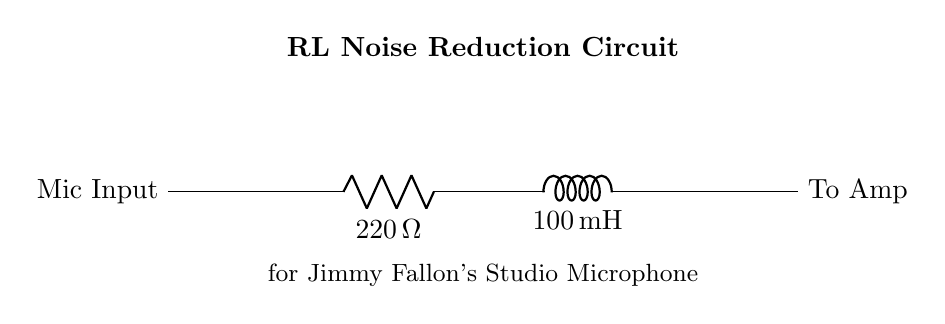What is the resistance value in this circuit? The circuit shows a resistor labeled "R" with the value stated explicitly as "220 Ω". Thus, the resistance value is directly given in the diagram.
Answer: 220 Ω What is the inductance value in this circuit? The circuit features an inductor labeled "L" with the value recorded as "100 mH". The inductance value is clearly stated in the diagram.
Answer: 100 mH What is the purpose of this RL circuit? The purpose is indicated in the circuit label, which states it is for "Noise Reduction" specifically for Jimmy Fallon's studio microphone. It suggests that the circuit is designed to reduce unwanted noise from the microphone input.
Answer: Noise Reduction Where does the microphone input connect in the circuit? The microphone input connects to the left side of the resistor "R", as seen in the diagram where there is a labeled input connection at that point.
Answer: To the left of the resistor How does the RL circuit help in noise reduction? An RL circuit helps in noise reduction by allowing low-frequency signals (like the voice) to pass through while attenuating higher-frequency noise due to the nature of inductors which resist changes in current. This behavior is typical of RL circuits.
Answer: By allowing low frequencies to pass What will happen if the value of the resistor is increased? Increasing the resistance would reduce the current flow in the circuit, potentially resulting in a lower output signal level to the amplifier, which could affect the overall gain and effectiveness in processing the microphone signal.
Answer: Lower output signal 